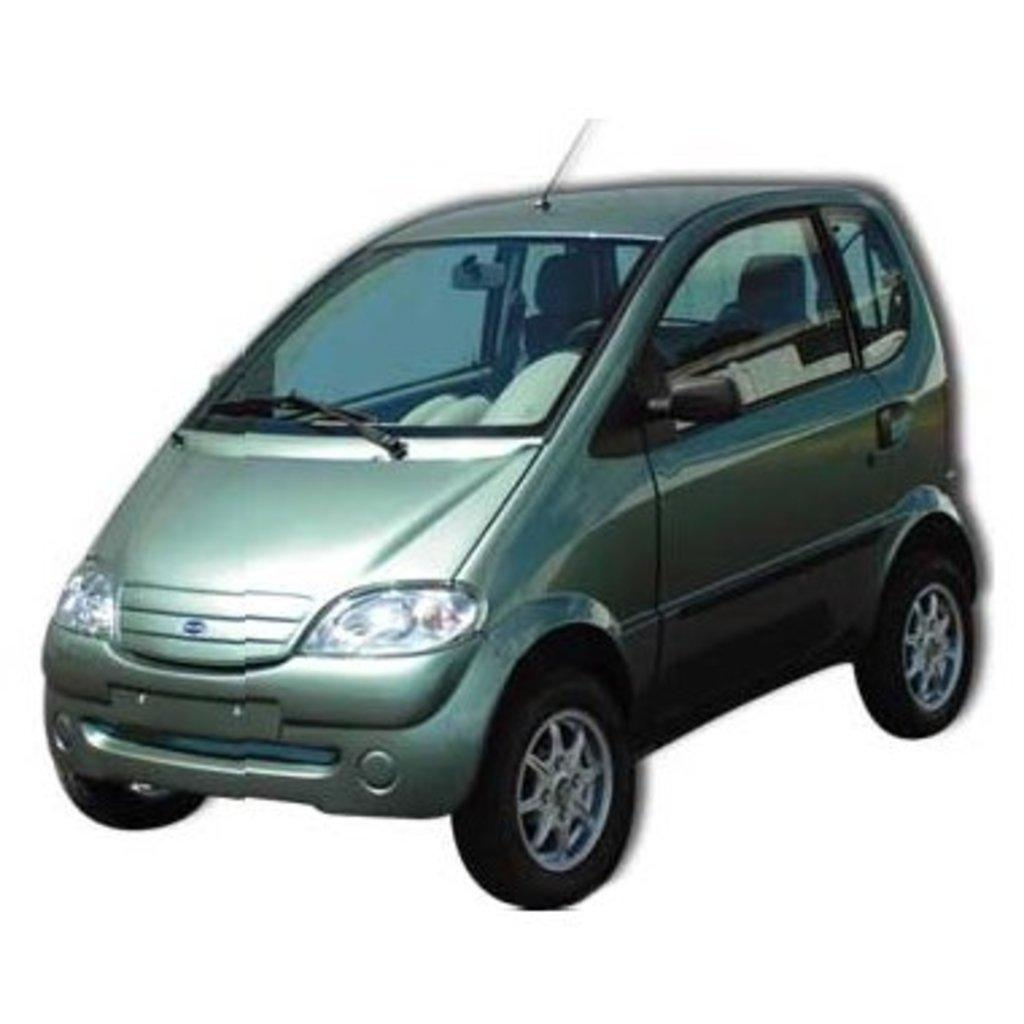What is the main subject of the image? There is a car in the image. What can be seen in the background of the image? The background of the image is white. What type of fiction is the car reading in the image? There is no indication in the image that the car is reading any fiction, as cars do not have the ability to read. 